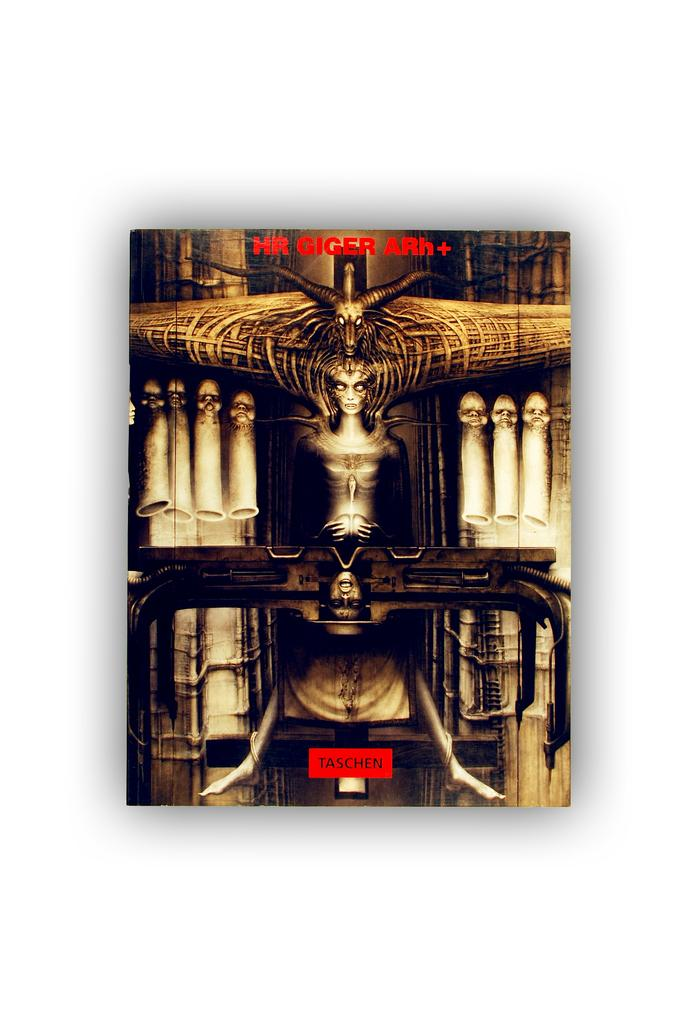Provide a one-sentence caption for the provided image. A poster that is made by HR Giger. 